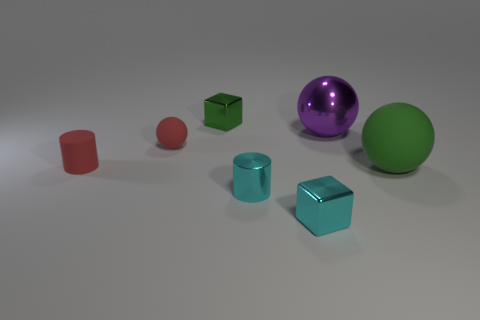Add 2 brown shiny cylinders. How many objects exist? 9 Subtract all balls. How many objects are left? 4 Add 3 gray metallic cubes. How many gray metallic cubes exist? 3 Subtract 0 red blocks. How many objects are left? 7 Subtract all red rubber objects. Subtract all small blocks. How many objects are left? 3 Add 6 big purple metal balls. How many big purple metal balls are left? 7 